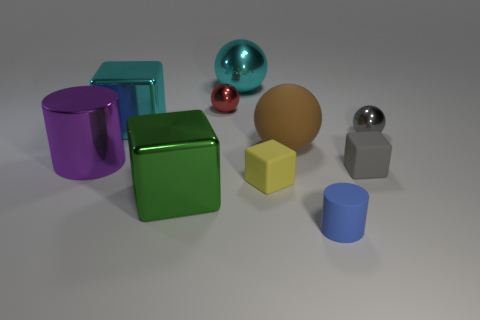What color is the large shiny cylinder?
Your answer should be compact. Purple. There is a large metal ball; does it have the same color as the large shiny cube behind the tiny gray sphere?
Give a very brief answer. Yes. How many big cubes are the same color as the big shiny ball?
Provide a short and direct response. 1. What number of balls are tiny yellow things or small gray rubber things?
Give a very brief answer. 0. Are there any tiny gray metal objects of the same shape as the small gray matte thing?
Give a very brief answer. No. There is a gray rubber thing; what shape is it?
Your response must be concise. Cube. What number of objects are green shiny blocks or purple shiny things?
Your answer should be very brief. 2. There is a sphere on the right side of the brown thing; does it have the same size as the rubber cube on the left side of the big brown matte sphere?
Keep it short and to the point. Yes. How many other objects are the same material as the tiny red sphere?
Ensure brevity in your answer.  5. Are there more rubber blocks left of the blue thing than red things on the left side of the large cylinder?
Make the answer very short. Yes. 